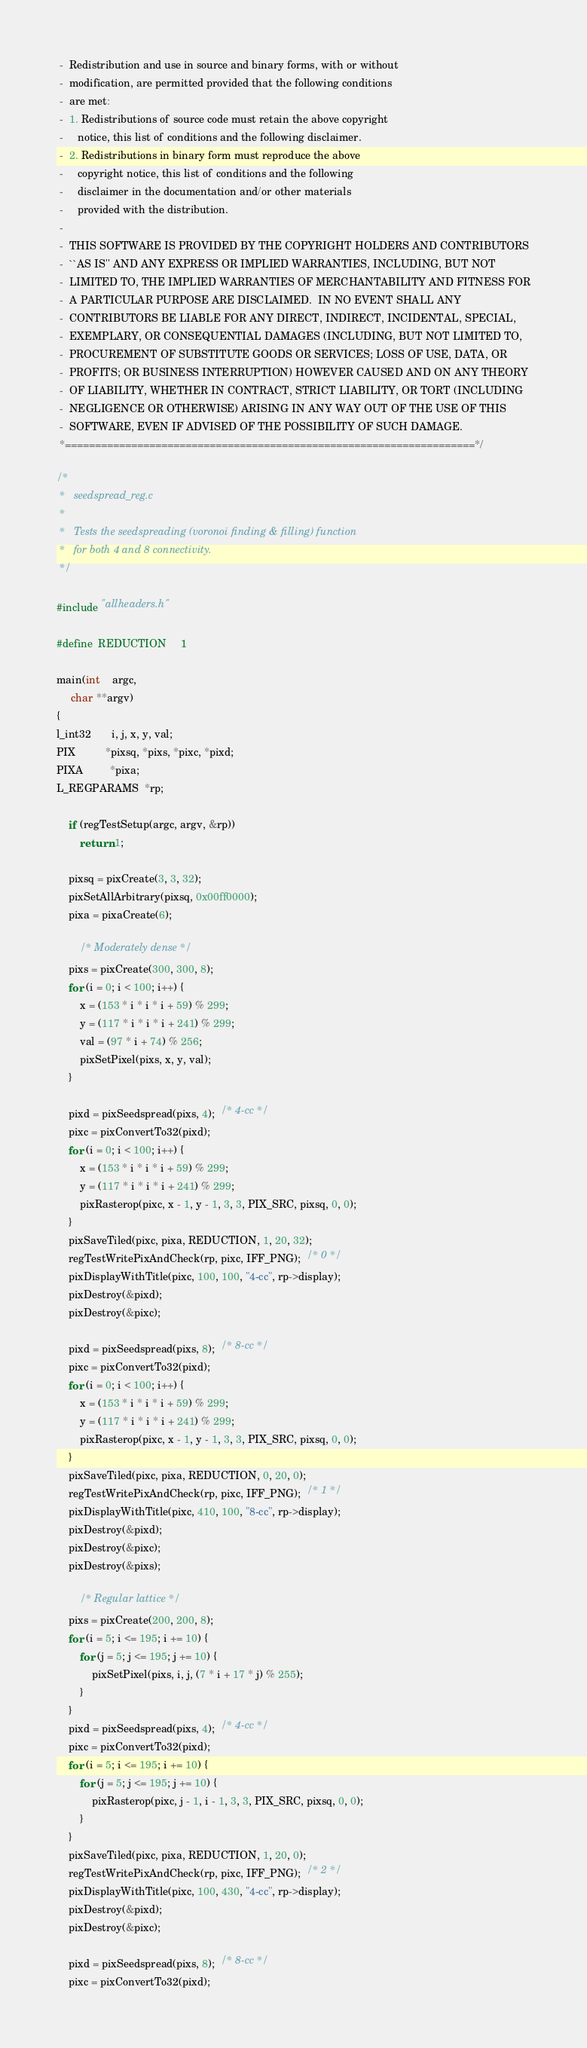<code> <loc_0><loc_0><loc_500><loc_500><_C_> -  Redistribution and use in source and binary forms, with or without
 -  modification, are permitted provided that the following conditions
 -  are met:
 -  1. Redistributions of source code must retain the above copyright
 -     notice, this list of conditions and the following disclaimer.
 -  2. Redistributions in binary form must reproduce the above
 -     copyright notice, this list of conditions and the following
 -     disclaimer in the documentation and/or other materials
 -     provided with the distribution.
 -
 -  THIS SOFTWARE IS PROVIDED BY THE COPYRIGHT HOLDERS AND CONTRIBUTORS
 -  ``AS IS'' AND ANY EXPRESS OR IMPLIED WARRANTIES, INCLUDING, BUT NOT
 -  LIMITED TO, THE IMPLIED WARRANTIES OF MERCHANTABILITY AND FITNESS FOR
 -  A PARTICULAR PURPOSE ARE DISCLAIMED.  IN NO EVENT SHALL ANY
 -  CONTRIBUTORS BE LIABLE FOR ANY DIRECT, INDIRECT, INCIDENTAL, SPECIAL,
 -  EXEMPLARY, OR CONSEQUENTIAL DAMAGES (INCLUDING, BUT NOT LIMITED TO,
 -  PROCUREMENT OF SUBSTITUTE GOODS OR SERVICES; LOSS OF USE, DATA, OR
 -  PROFITS; OR BUSINESS INTERRUPTION) HOWEVER CAUSED AND ON ANY THEORY
 -  OF LIABILITY, WHETHER IN CONTRACT, STRICT LIABILITY, OR TORT (INCLUDING
 -  NEGLIGENCE OR OTHERWISE) ARISING IN ANY WAY OUT OF THE USE OF THIS
 -  SOFTWARE, EVEN IF ADVISED OF THE POSSIBILITY OF SUCH DAMAGE.
 *====================================================================*/

/*
 *   seedspread_reg.c
 *
 *   Tests the seedspreading (voronoi finding & filling) function
 *   for both 4 and 8 connectivity.
 */

#include "allheaders.h"

#define  REDUCTION     1

main(int    argc,
     char **argv)
{
l_int32       i, j, x, y, val;
PIX          *pixsq, *pixs, *pixc, *pixd;
PIXA         *pixa;
L_REGPARAMS  *rp;

    if (regTestSetup(argc, argv, &rp))
        return 1;

    pixsq = pixCreate(3, 3, 32);
    pixSetAllArbitrary(pixsq, 0x00ff0000);
    pixa = pixaCreate(6);

        /* Moderately dense */
    pixs = pixCreate(300, 300, 8);
    for (i = 0; i < 100; i++) {
        x = (153 * i * i * i + 59) % 299;
        y = (117 * i * i * i + 241) % 299;
        val = (97 * i + 74) % 256;
        pixSetPixel(pixs, x, y, val);
    }

    pixd = pixSeedspread(pixs, 4);  /* 4-cc */
    pixc = pixConvertTo32(pixd);
    for (i = 0; i < 100; i++) {
        x = (153 * i * i * i + 59) % 299;
        y = (117 * i * i * i + 241) % 299;
        pixRasterop(pixc, x - 1, y - 1, 3, 3, PIX_SRC, pixsq, 0, 0);
    }
    pixSaveTiled(pixc, pixa, REDUCTION, 1, 20, 32);
    regTestWritePixAndCheck(rp, pixc, IFF_PNG);  /* 0 */
    pixDisplayWithTitle(pixc, 100, 100, "4-cc", rp->display);
    pixDestroy(&pixd);
    pixDestroy(&pixc);

    pixd = pixSeedspread(pixs, 8);  /* 8-cc */
    pixc = pixConvertTo32(pixd);
    for (i = 0; i < 100; i++) {
        x = (153 * i * i * i + 59) % 299;
        y = (117 * i * i * i + 241) % 299;
        pixRasterop(pixc, x - 1, y - 1, 3, 3, PIX_SRC, pixsq, 0, 0);
    }
    pixSaveTiled(pixc, pixa, REDUCTION, 0, 20, 0);
    regTestWritePixAndCheck(rp, pixc, IFF_PNG);  /* 1 */
    pixDisplayWithTitle(pixc, 410, 100, "8-cc", rp->display);
    pixDestroy(&pixd);
    pixDestroy(&pixc);
    pixDestroy(&pixs);

        /* Regular lattice */
    pixs = pixCreate(200, 200, 8);
    for (i = 5; i <= 195; i += 10) {
        for (j = 5; j <= 195; j += 10) {
            pixSetPixel(pixs, i, j, (7 * i + 17 * j) % 255);
        }
    }
    pixd = pixSeedspread(pixs, 4);  /* 4-cc */
    pixc = pixConvertTo32(pixd);
    for (i = 5; i <= 195; i += 10) {
        for (j = 5; j <= 195; j += 10) {
            pixRasterop(pixc, j - 1, i - 1, 3, 3, PIX_SRC, pixsq, 0, 0);
        }
    }
    pixSaveTiled(pixc, pixa, REDUCTION, 1, 20, 0);
    regTestWritePixAndCheck(rp, pixc, IFF_PNG);  /* 2 */
    pixDisplayWithTitle(pixc, 100, 430, "4-cc", rp->display);
    pixDestroy(&pixd);
    pixDestroy(&pixc);

    pixd = pixSeedspread(pixs, 8);  /* 8-cc */
    pixc = pixConvertTo32(pixd);</code> 